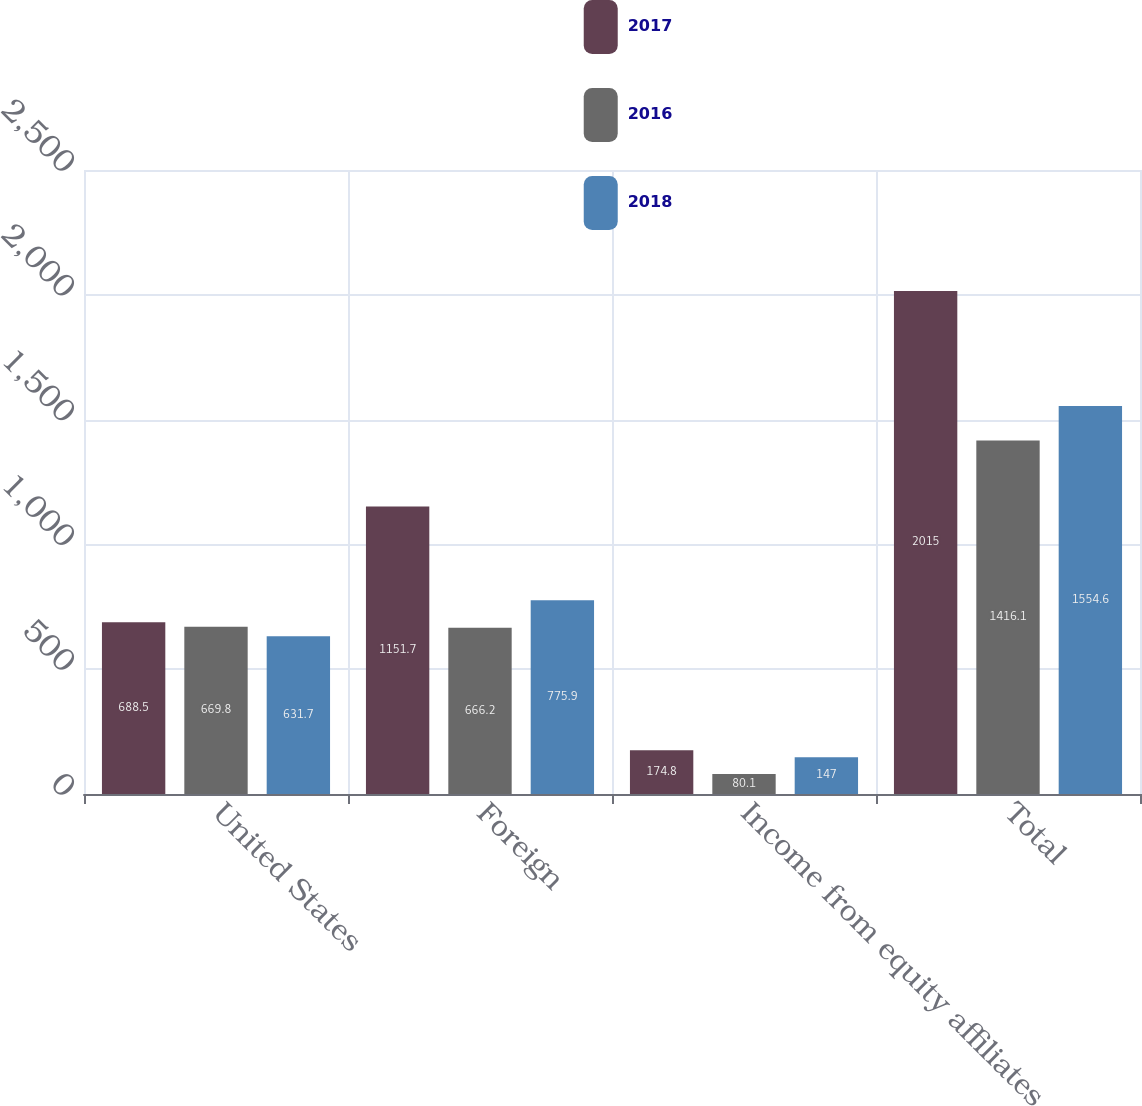Convert chart. <chart><loc_0><loc_0><loc_500><loc_500><stacked_bar_chart><ecel><fcel>United States<fcel>Foreign<fcel>Income from equity affiliates<fcel>Total<nl><fcel>2017<fcel>688.5<fcel>1151.7<fcel>174.8<fcel>2015<nl><fcel>2016<fcel>669.8<fcel>666.2<fcel>80.1<fcel>1416.1<nl><fcel>2018<fcel>631.7<fcel>775.9<fcel>147<fcel>1554.6<nl></chart> 